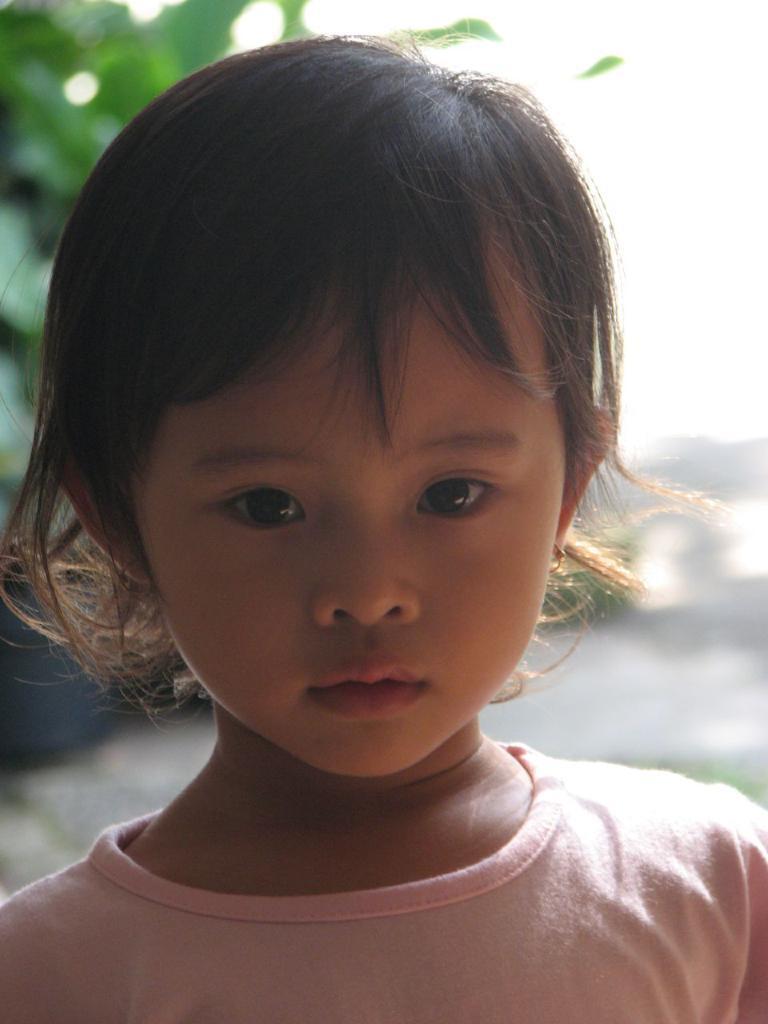Could you give a brief overview of what you see in this image? In this image I can see the person is wearing peach color dress. Background is blurred. 